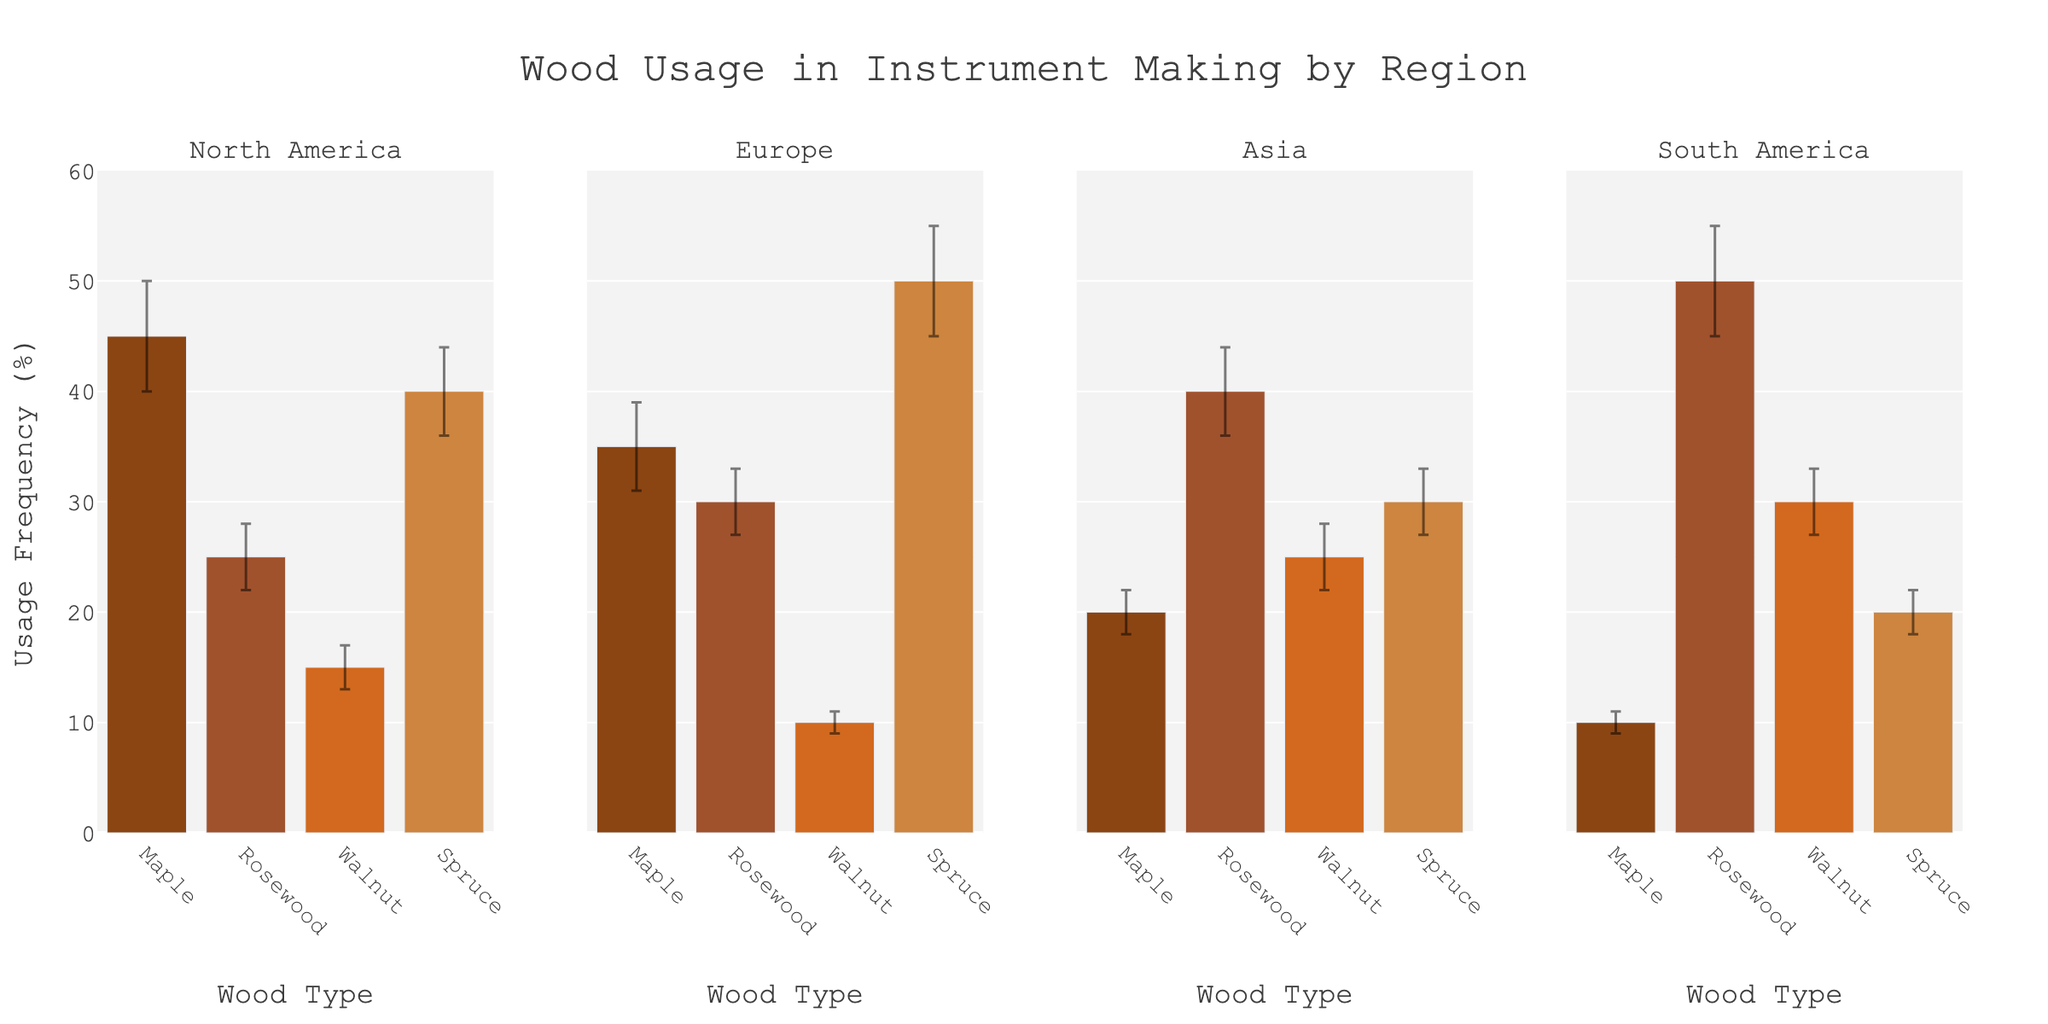What's the title of the chart? The title of the chart is displayed at the top, providing a description of the figure's content.
Answer: Wood Usage in Instrument Making by Region What's the wood type with the highest usage in Europe? Look for the tallest bar in the Europe subplot and identify the corresponding wood type on the x-axis.
Answer: Spruce How does the usage of Rosewood in North America compare with that in Asia? Compare the height of the Rosewood bars in the North America and Asia subplots. Rosewood's usage is higher in Asia.
Answer: Higher in Asia Which region shows the least variability in Walnut usage? Check the error bars on the Walnut bars in each region's subplot and identify the smallest error bar.
Answer: Europe What is the difference in usage frequency of Maple between North America and South America? Subtract the usage frequency of Maple in South America from that in North America. Maple's usage is 45 in North America and 10 in South America. The difference is 45 - 10.
Answer: 35 Which wood type has the largest error bar in South America? Examine the error bars in the South America subplot and identify the wood type with the highest error bar. Rosewood has the largest error bar.
Answer: Rosewood On average, how frequently is Walnut used across all regions? Calculate the average of Walnut's usage frequency across North America, Europe, Asia, and South America. The values are 15, 10, 25, and 30. Average = (15 + 10 + 25 + 30) / 4.
Answer: 20 Which region has the highest average usage frequency of all wood types combined? Sum the usage frequencies for all wood types in each region and divide by the number of wood types (4), then compare the averages. North America: (45+25+15+40)/4 = 31.25; Europe: (35+30+10+50)/4 = 31.25; Asia: (20+40+25+30)/4 = 28.75; South America: (10+50+30+20)/4 = 27.5.
Answer: North America and Europe (Tie) Which wood type appears to have the highest variability in usage across all regions? Compare the lengths of the error bars across all wood types in each subplot. Spruce and Rosewood repeatedly show larger error bars.
Answer: Rosewood and Spruce 